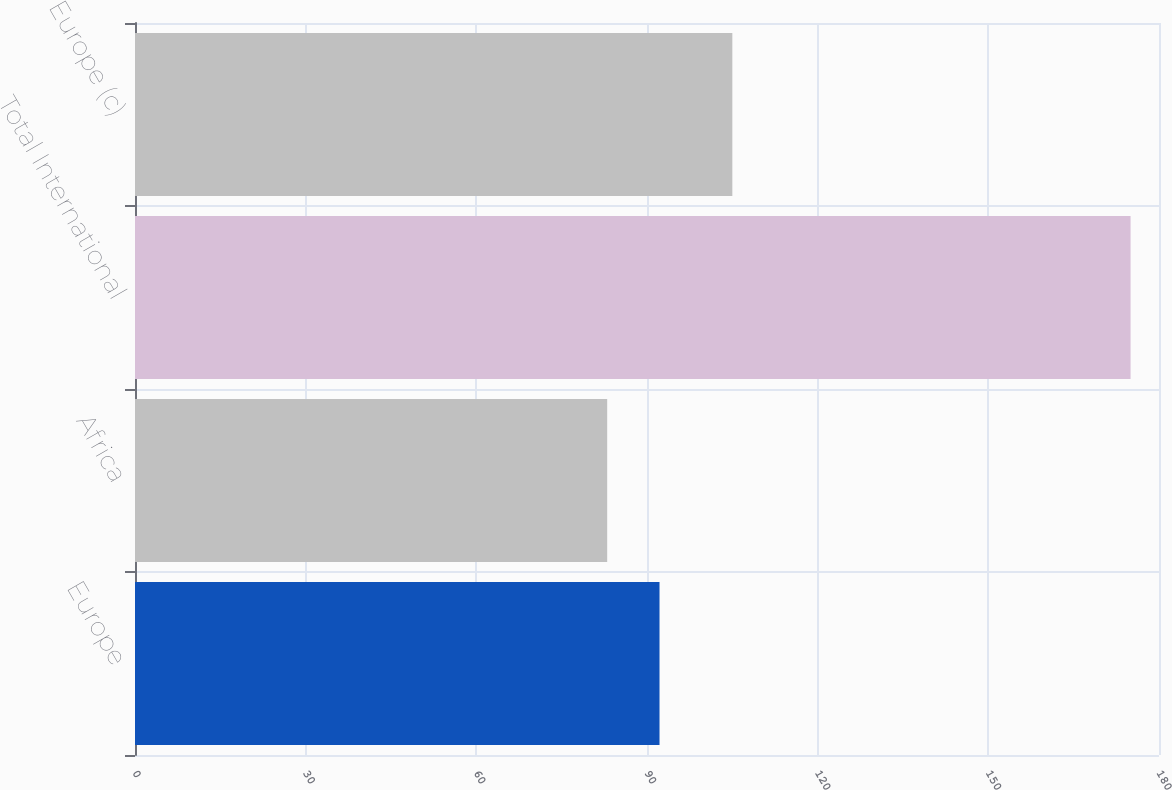<chart> <loc_0><loc_0><loc_500><loc_500><bar_chart><fcel>Europe<fcel>Africa<fcel>Total International<fcel>Europe (c)<nl><fcel>92.2<fcel>83<fcel>175<fcel>105<nl></chart> 